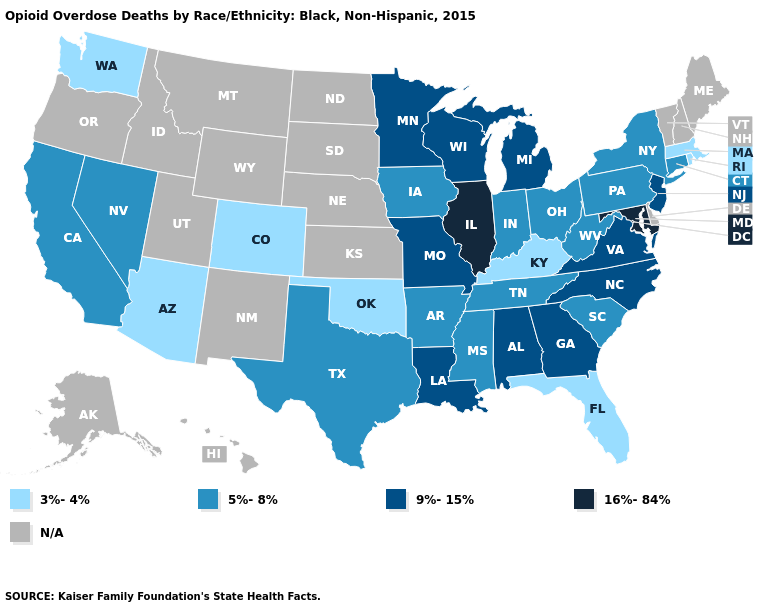What is the highest value in the South ?
Short answer required. 16%-84%. What is the lowest value in the South?
Concise answer only. 3%-4%. Which states have the lowest value in the MidWest?
Give a very brief answer. Indiana, Iowa, Ohio. What is the value of Illinois?
Answer briefly. 16%-84%. Name the states that have a value in the range 9%-15%?
Keep it brief. Alabama, Georgia, Louisiana, Michigan, Minnesota, Missouri, New Jersey, North Carolina, Virginia, Wisconsin. Name the states that have a value in the range N/A?
Answer briefly. Alaska, Delaware, Hawaii, Idaho, Kansas, Maine, Montana, Nebraska, New Hampshire, New Mexico, North Dakota, Oregon, South Dakota, Utah, Vermont, Wyoming. Name the states that have a value in the range 16%-84%?
Concise answer only. Illinois, Maryland. What is the value of Missouri?
Keep it brief. 9%-15%. Which states have the highest value in the USA?
Concise answer only. Illinois, Maryland. Name the states that have a value in the range 3%-4%?
Concise answer only. Arizona, Colorado, Florida, Kentucky, Massachusetts, Oklahoma, Rhode Island, Washington. Does Illinois have the highest value in the MidWest?
Keep it brief. Yes. What is the lowest value in the USA?
Write a very short answer. 3%-4%. Does New York have the highest value in the Northeast?
Write a very short answer. No. Name the states that have a value in the range 3%-4%?
Keep it brief. Arizona, Colorado, Florida, Kentucky, Massachusetts, Oklahoma, Rhode Island, Washington. Name the states that have a value in the range 3%-4%?
Answer briefly. Arizona, Colorado, Florida, Kentucky, Massachusetts, Oklahoma, Rhode Island, Washington. 